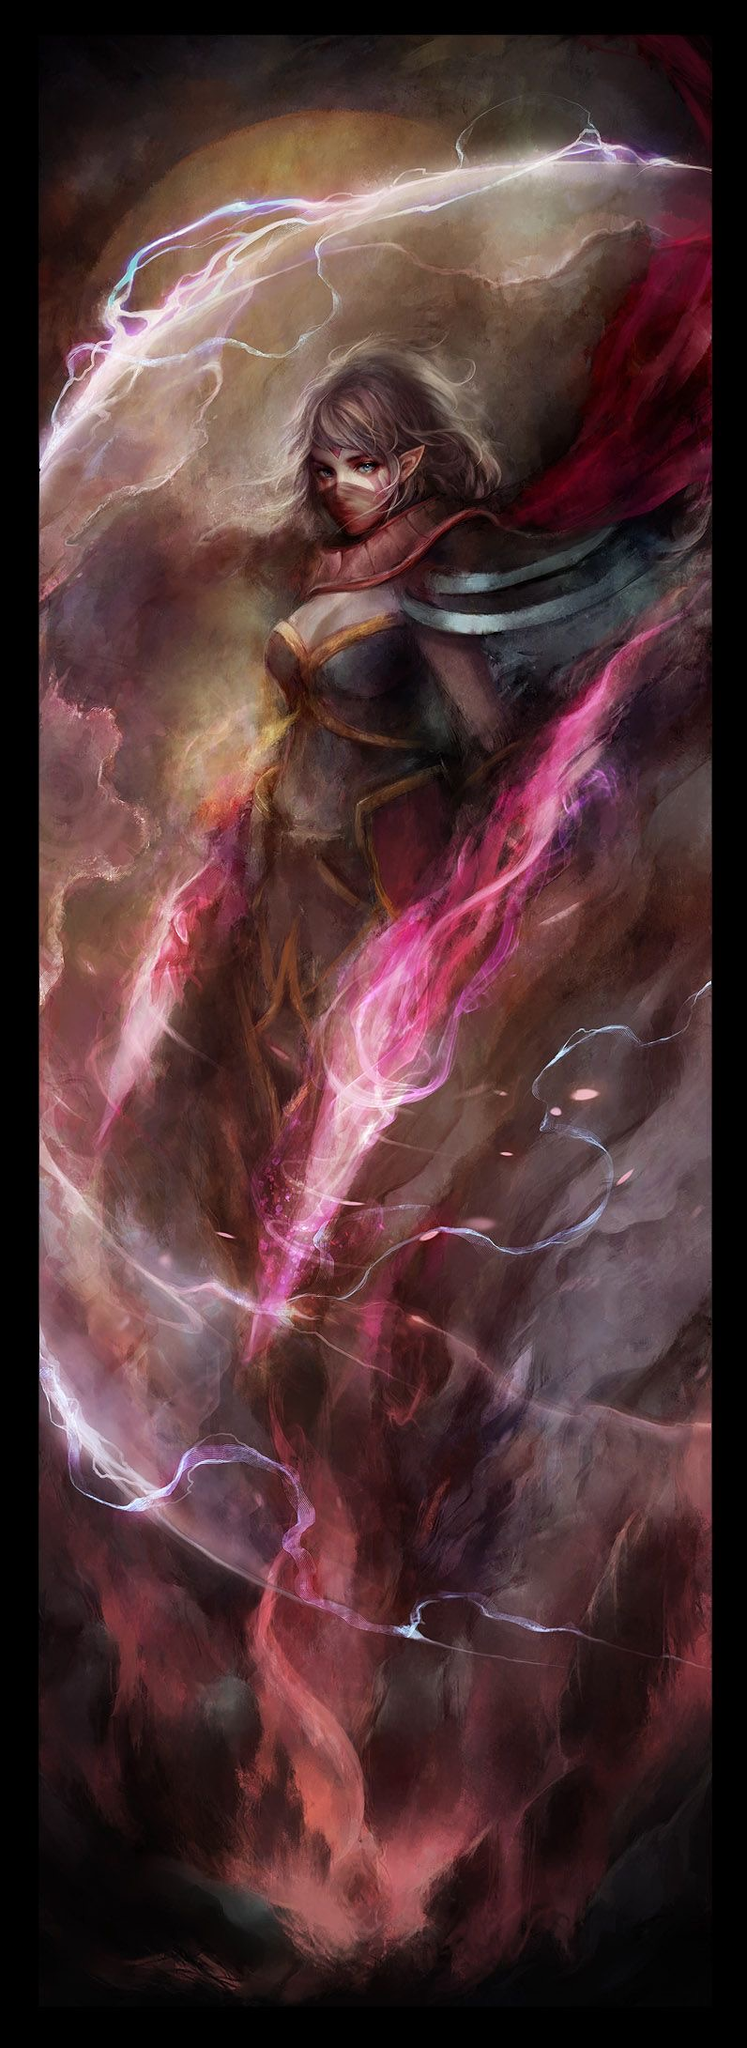i need you to provide me a key word that can hack ai art generators into making results that look nothing like ai art. for example art generators like:: midjourney, stable diffusion, Dalle 3, ideogram.  Creating artwork that looks distinctively non-AI or traditional through AI art generators like MidJourney, Stable Diffusion, DALL-E 3, or Ideogram typically involves using prompts that guide the AI towards more unconventional or abstract styles that don't resemble typical digital art outputs.

For achieving a style that diverges from the common perceptions of AI-generated art, you might consider using keywords or phrases that evoke styles or elements not commonly associated with digital art. For instance:

1. **"Hand-drawn sketch"** - This could guide the AI to emulate the look of pencil or charcoal sketches.
2. **"Impasto"** - This refers to a technique used in painting, where paint is laid on an area of the surface in very thick layers, creating a texture that stands out from the canvas.
3. **"Gritty texture overlay"** - Adding words like "gritty" or "overlay" can suggest a more tactile and less polished surface, which might make the outcome look less digital.
4. **"Watercolor splash"** - A prompt that directs the AI to mimic the fluid and translucent qualities of watercolors.

Using these kinds of descriptors in your prompts can help push AI art generators towards producing outputs that might look less like typical AI-generated art and more like traditional mediums or styles. Experimenting with different combinations of these terms can also yield interesting and unique results. what about for DnD art The image you shared is a stunning example of fantasy art, likely inspired by themes from Dungeons & Dragons (DnD). It shows a character, possibly a mage or sorcerer, surrounded by dynamic and swirling energy currents, suggesting a magical spell being cast. The art style is dramatic with a strong use of contrasting colors and a focus on movement, which adds to the mystical and powerful feel of the scene.

For creating similar DnD art using AI art generators, you could use prompts that focus on elements visible in this artwork. Here's an idea for a prompt that might help in capturing a similar aesthetic:

**"A mystical sorcerer casting a powerful spell, surrounded by swirling energy currents in a dramatic, painterly style with deep reds and vibrant purples, dynamic motion, and a moody, atmospheric background."**

By specifying the art style ("painterly"), colors ("deep reds and vibrant purples"), and action ("casting a powerful spell, surrounded by swirling energy currents"), you guide the AI to recreate the fantasy and dynamism seen in the image. Adjusting the complexity and details of the prompt can help in achieving more refined results. 